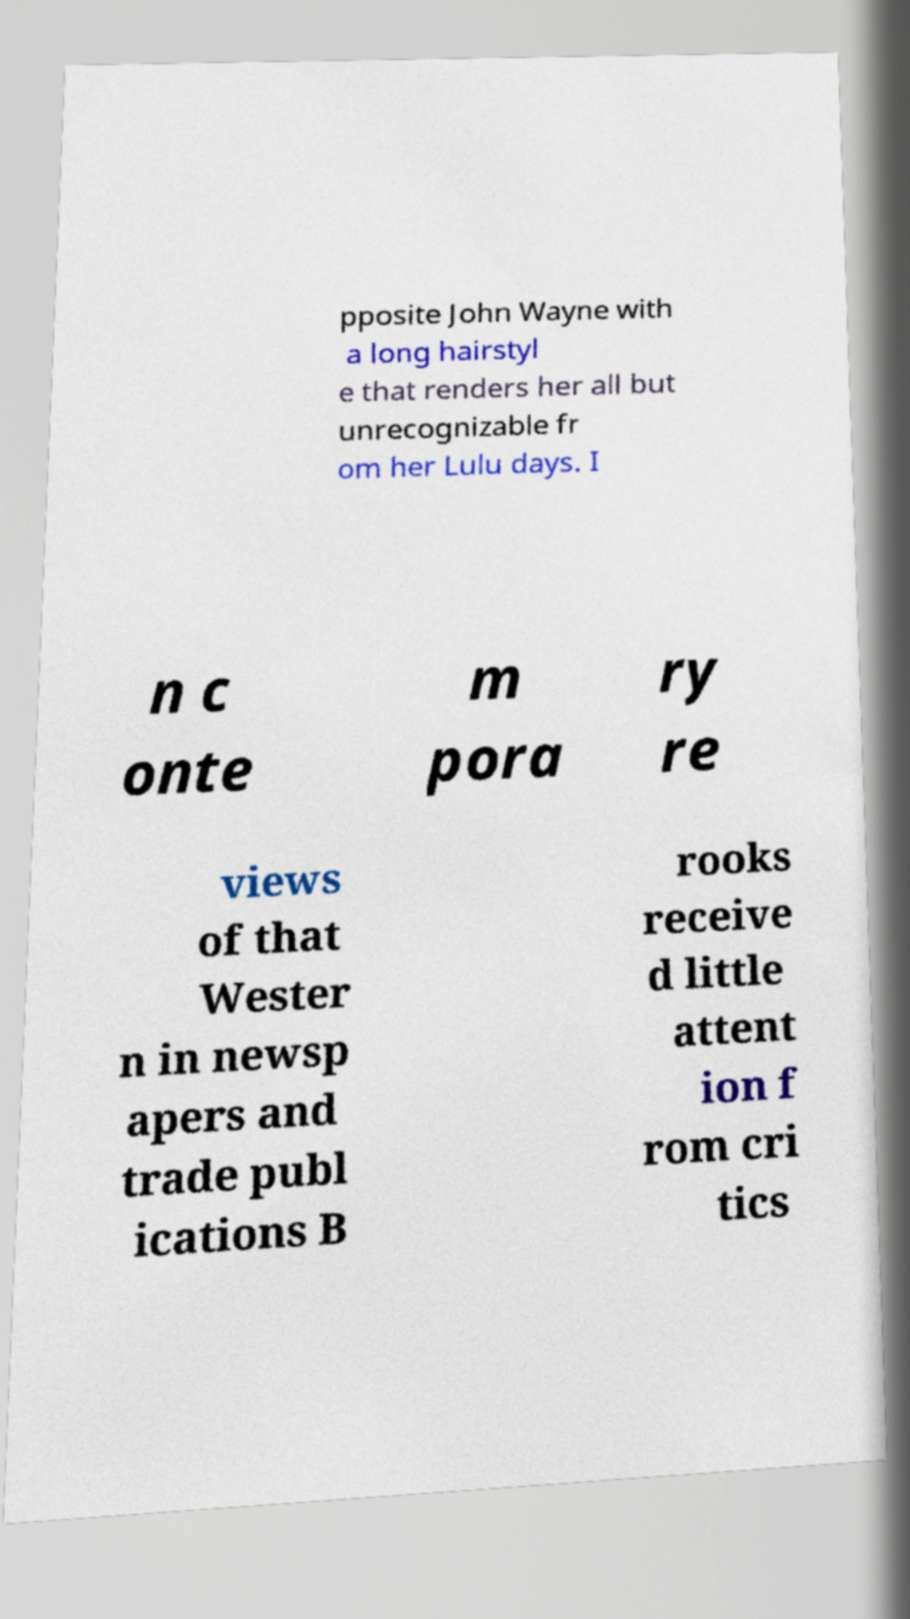I need the written content from this picture converted into text. Can you do that? pposite John Wayne with a long hairstyl e that renders her all but unrecognizable fr om her Lulu days. I n c onte m pora ry re views of that Wester n in newsp apers and trade publ ications B rooks receive d little attent ion f rom cri tics 